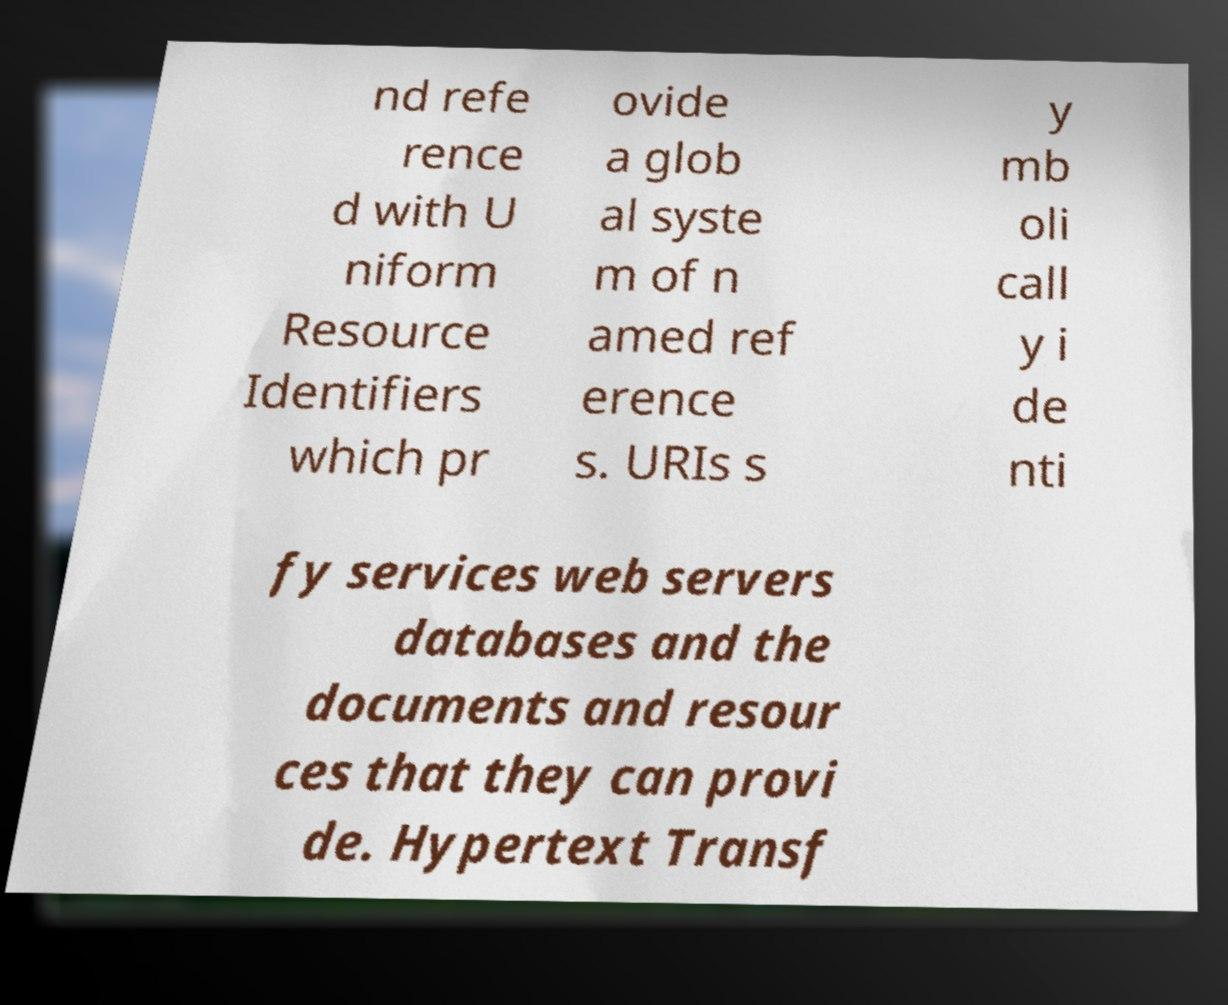Could you assist in decoding the text presented in this image and type it out clearly? nd refe rence d with U niform Resource Identifiers which pr ovide a glob al syste m of n amed ref erence s. URIs s y mb oli call y i de nti fy services web servers databases and the documents and resour ces that they can provi de. Hypertext Transf 